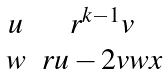<formula> <loc_0><loc_0><loc_500><loc_500>\begin{matrix} u & r ^ { k - 1 } v \\ w & r u - 2 v w x \end{matrix}</formula> 